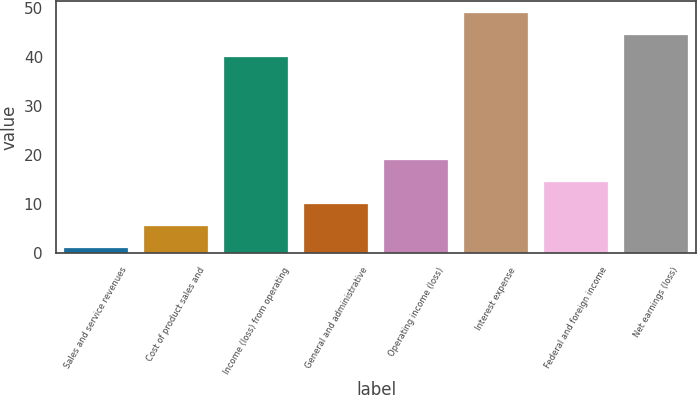Convert chart. <chart><loc_0><loc_0><loc_500><loc_500><bar_chart><fcel>Sales and service revenues<fcel>Cost of product sales and<fcel>Income (loss) from operating<fcel>General and administrative<fcel>Operating income (loss)<fcel>Interest expense<fcel>Federal and foreign income<fcel>Net earnings (loss)<nl><fcel>1<fcel>5.5<fcel>40<fcel>10<fcel>19<fcel>49<fcel>14.5<fcel>44.5<nl></chart> 